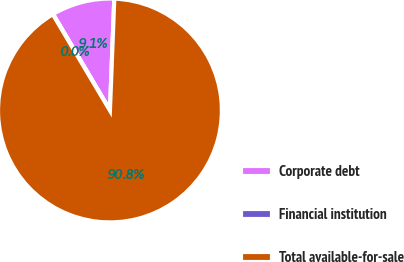<chart> <loc_0><loc_0><loc_500><loc_500><pie_chart><fcel>Corporate debt<fcel>Financial institution<fcel>Total available-for-sale<nl><fcel>9.12%<fcel>0.03%<fcel>90.85%<nl></chart> 